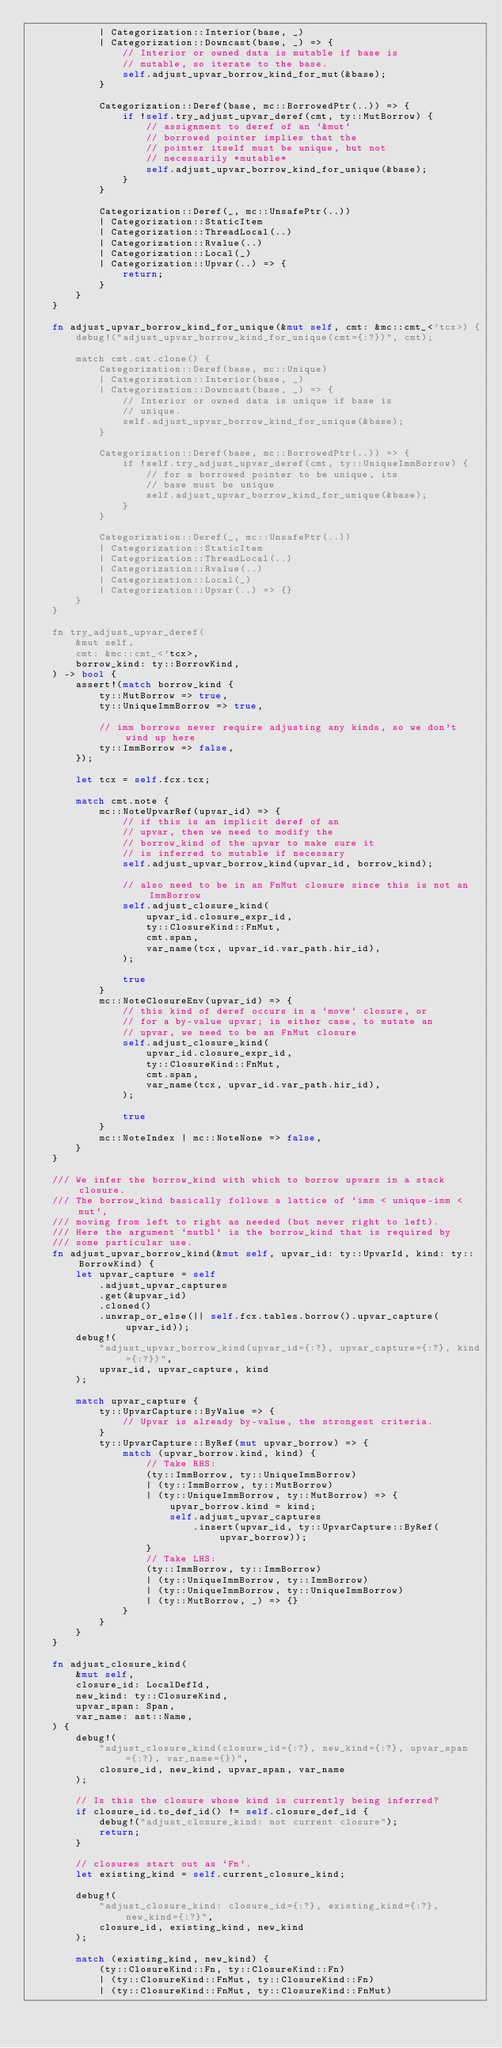Convert code to text. <code><loc_0><loc_0><loc_500><loc_500><_Rust_>            | Categorization::Interior(base, _)
            | Categorization::Downcast(base, _) => {
                // Interior or owned data is mutable if base is
                // mutable, so iterate to the base.
                self.adjust_upvar_borrow_kind_for_mut(&base);
            }

            Categorization::Deref(base, mc::BorrowedPtr(..)) => {
                if !self.try_adjust_upvar_deref(cmt, ty::MutBorrow) {
                    // assignment to deref of an `&mut`
                    // borrowed pointer implies that the
                    // pointer itself must be unique, but not
                    // necessarily *mutable*
                    self.adjust_upvar_borrow_kind_for_unique(&base);
                }
            }

            Categorization::Deref(_, mc::UnsafePtr(..))
            | Categorization::StaticItem
            | Categorization::ThreadLocal(..)
            | Categorization::Rvalue(..)
            | Categorization::Local(_)
            | Categorization::Upvar(..) => {
                return;
            }
        }
    }

    fn adjust_upvar_borrow_kind_for_unique(&mut self, cmt: &mc::cmt_<'tcx>) {
        debug!("adjust_upvar_borrow_kind_for_unique(cmt={:?})", cmt);

        match cmt.cat.clone() {
            Categorization::Deref(base, mc::Unique)
            | Categorization::Interior(base, _)
            | Categorization::Downcast(base, _) => {
                // Interior or owned data is unique if base is
                // unique.
                self.adjust_upvar_borrow_kind_for_unique(&base);
            }

            Categorization::Deref(base, mc::BorrowedPtr(..)) => {
                if !self.try_adjust_upvar_deref(cmt, ty::UniqueImmBorrow) {
                    // for a borrowed pointer to be unique, its
                    // base must be unique
                    self.adjust_upvar_borrow_kind_for_unique(&base);
                }
            }

            Categorization::Deref(_, mc::UnsafePtr(..))
            | Categorization::StaticItem
            | Categorization::ThreadLocal(..)
            | Categorization::Rvalue(..)
            | Categorization::Local(_)
            | Categorization::Upvar(..) => {}
        }
    }

    fn try_adjust_upvar_deref(
        &mut self,
        cmt: &mc::cmt_<'tcx>,
        borrow_kind: ty::BorrowKind,
    ) -> bool {
        assert!(match borrow_kind {
            ty::MutBorrow => true,
            ty::UniqueImmBorrow => true,

            // imm borrows never require adjusting any kinds, so we don't wind up here
            ty::ImmBorrow => false,
        });

        let tcx = self.fcx.tcx;

        match cmt.note {
            mc::NoteUpvarRef(upvar_id) => {
                // if this is an implicit deref of an
                // upvar, then we need to modify the
                // borrow_kind of the upvar to make sure it
                // is inferred to mutable if necessary
                self.adjust_upvar_borrow_kind(upvar_id, borrow_kind);

                // also need to be in an FnMut closure since this is not an ImmBorrow
                self.adjust_closure_kind(
                    upvar_id.closure_expr_id,
                    ty::ClosureKind::FnMut,
                    cmt.span,
                    var_name(tcx, upvar_id.var_path.hir_id),
                );

                true
            }
            mc::NoteClosureEnv(upvar_id) => {
                // this kind of deref occurs in a `move` closure, or
                // for a by-value upvar; in either case, to mutate an
                // upvar, we need to be an FnMut closure
                self.adjust_closure_kind(
                    upvar_id.closure_expr_id,
                    ty::ClosureKind::FnMut,
                    cmt.span,
                    var_name(tcx, upvar_id.var_path.hir_id),
                );

                true
            }
            mc::NoteIndex | mc::NoteNone => false,
        }
    }

    /// We infer the borrow_kind with which to borrow upvars in a stack closure.
    /// The borrow_kind basically follows a lattice of `imm < unique-imm < mut`,
    /// moving from left to right as needed (but never right to left).
    /// Here the argument `mutbl` is the borrow_kind that is required by
    /// some particular use.
    fn adjust_upvar_borrow_kind(&mut self, upvar_id: ty::UpvarId, kind: ty::BorrowKind) {
        let upvar_capture = self
            .adjust_upvar_captures
            .get(&upvar_id)
            .cloned()
            .unwrap_or_else(|| self.fcx.tables.borrow().upvar_capture(upvar_id));
        debug!(
            "adjust_upvar_borrow_kind(upvar_id={:?}, upvar_capture={:?}, kind={:?})",
            upvar_id, upvar_capture, kind
        );

        match upvar_capture {
            ty::UpvarCapture::ByValue => {
                // Upvar is already by-value, the strongest criteria.
            }
            ty::UpvarCapture::ByRef(mut upvar_borrow) => {
                match (upvar_borrow.kind, kind) {
                    // Take RHS:
                    (ty::ImmBorrow, ty::UniqueImmBorrow)
                    | (ty::ImmBorrow, ty::MutBorrow)
                    | (ty::UniqueImmBorrow, ty::MutBorrow) => {
                        upvar_borrow.kind = kind;
                        self.adjust_upvar_captures
                            .insert(upvar_id, ty::UpvarCapture::ByRef(upvar_borrow));
                    }
                    // Take LHS:
                    (ty::ImmBorrow, ty::ImmBorrow)
                    | (ty::UniqueImmBorrow, ty::ImmBorrow)
                    | (ty::UniqueImmBorrow, ty::UniqueImmBorrow)
                    | (ty::MutBorrow, _) => {}
                }
            }
        }
    }

    fn adjust_closure_kind(
        &mut self,
        closure_id: LocalDefId,
        new_kind: ty::ClosureKind,
        upvar_span: Span,
        var_name: ast::Name,
    ) {
        debug!(
            "adjust_closure_kind(closure_id={:?}, new_kind={:?}, upvar_span={:?}, var_name={})",
            closure_id, new_kind, upvar_span, var_name
        );

        // Is this the closure whose kind is currently being inferred?
        if closure_id.to_def_id() != self.closure_def_id {
            debug!("adjust_closure_kind: not current closure");
            return;
        }

        // closures start out as `Fn`.
        let existing_kind = self.current_closure_kind;

        debug!(
            "adjust_closure_kind: closure_id={:?}, existing_kind={:?}, new_kind={:?}",
            closure_id, existing_kind, new_kind
        );

        match (existing_kind, new_kind) {
            (ty::ClosureKind::Fn, ty::ClosureKind::Fn)
            | (ty::ClosureKind::FnMut, ty::ClosureKind::Fn)
            | (ty::ClosureKind::FnMut, ty::ClosureKind::FnMut)</code> 